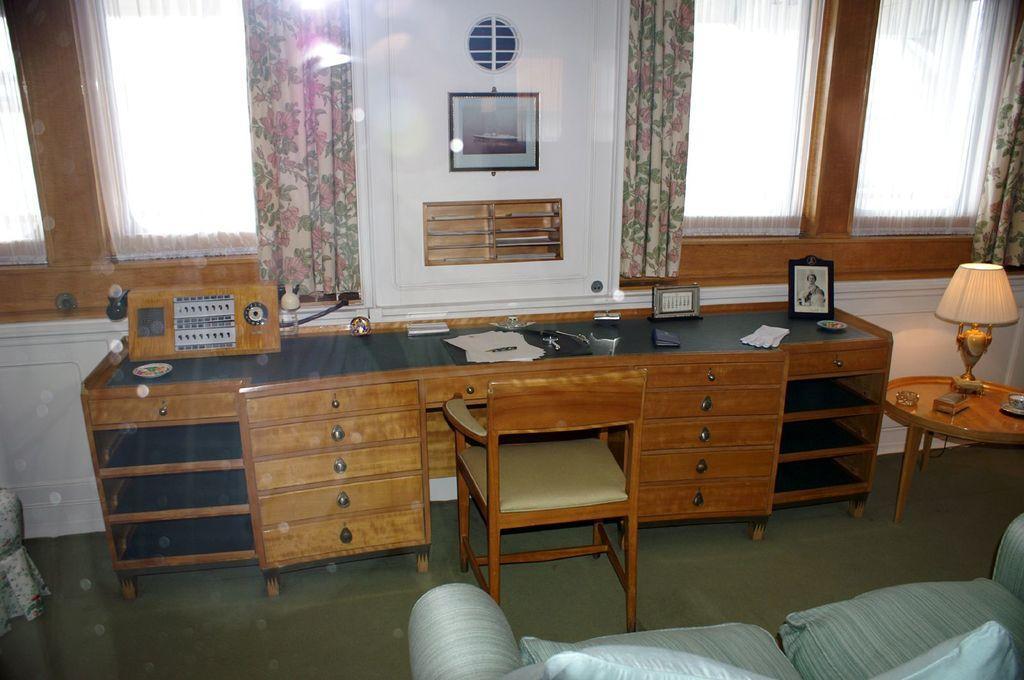Can you describe this image briefly? In this image I see a table and there is a chair in front of it and there are many things on the table. I also see that there is a sofa over here, a lamp, windows and curtains on it. 